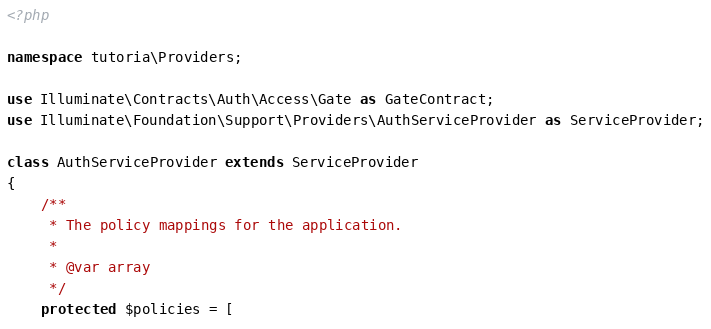Convert code to text. <code><loc_0><loc_0><loc_500><loc_500><_PHP_><?php

namespace tutoria\Providers;

use Illuminate\Contracts\Auth\Access\Gate as GateContract;
use Illuminate\Foundation\Support\Providers\AuthServiceProvider as ServiceProvider;

class AuthServiceProvider extends ServiceProvider
{
    /**
     * The policy mappings for the application.
     *
     * @var array
     */
    protected $policies = [</code> 